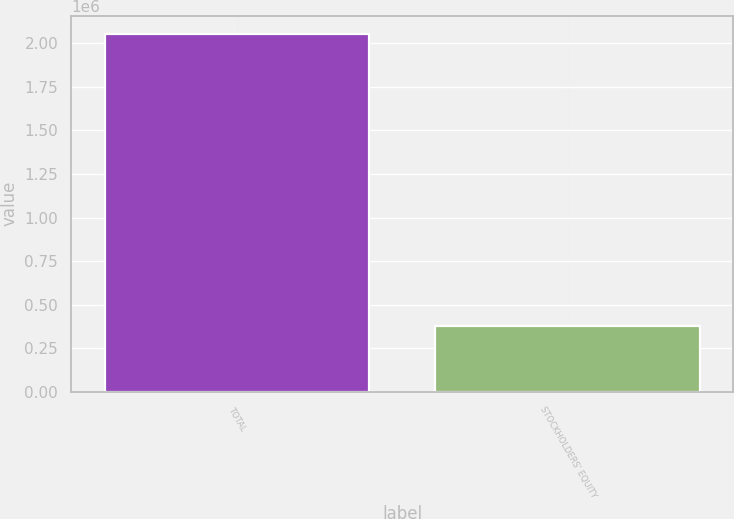Convert chart. <chart><loc_0><loc_0><loc_500><loc_500><bar_chart><fcel>TOTAL<fcel>STOCKHOLDERS' EQUITY<nl><fcel>2.0548e+06<fcel>379874<nl></chart> 